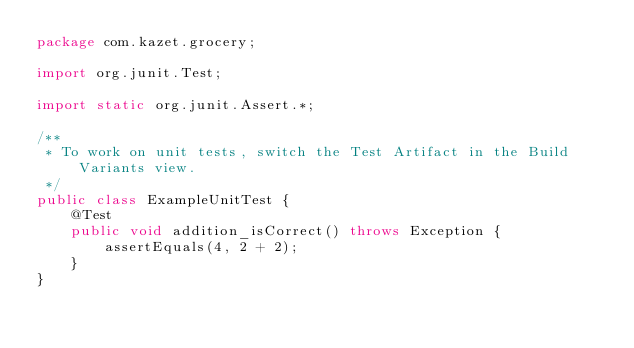<code> <loc_0><loc_0><loc_500><loc_500><_Java_>package com.kazet.grocery;

import org.junit.Test;

import static org.junit.Assert.*;

/**
 * To work on unit tests, switch the Test Artifact in the Build Variants view.
 */
public class ExampleUnitTest {
    @Test
    public void addition_isCorrect() throws Exception {
        assertEquals(4, 2 + 2);
    }
}</code> 